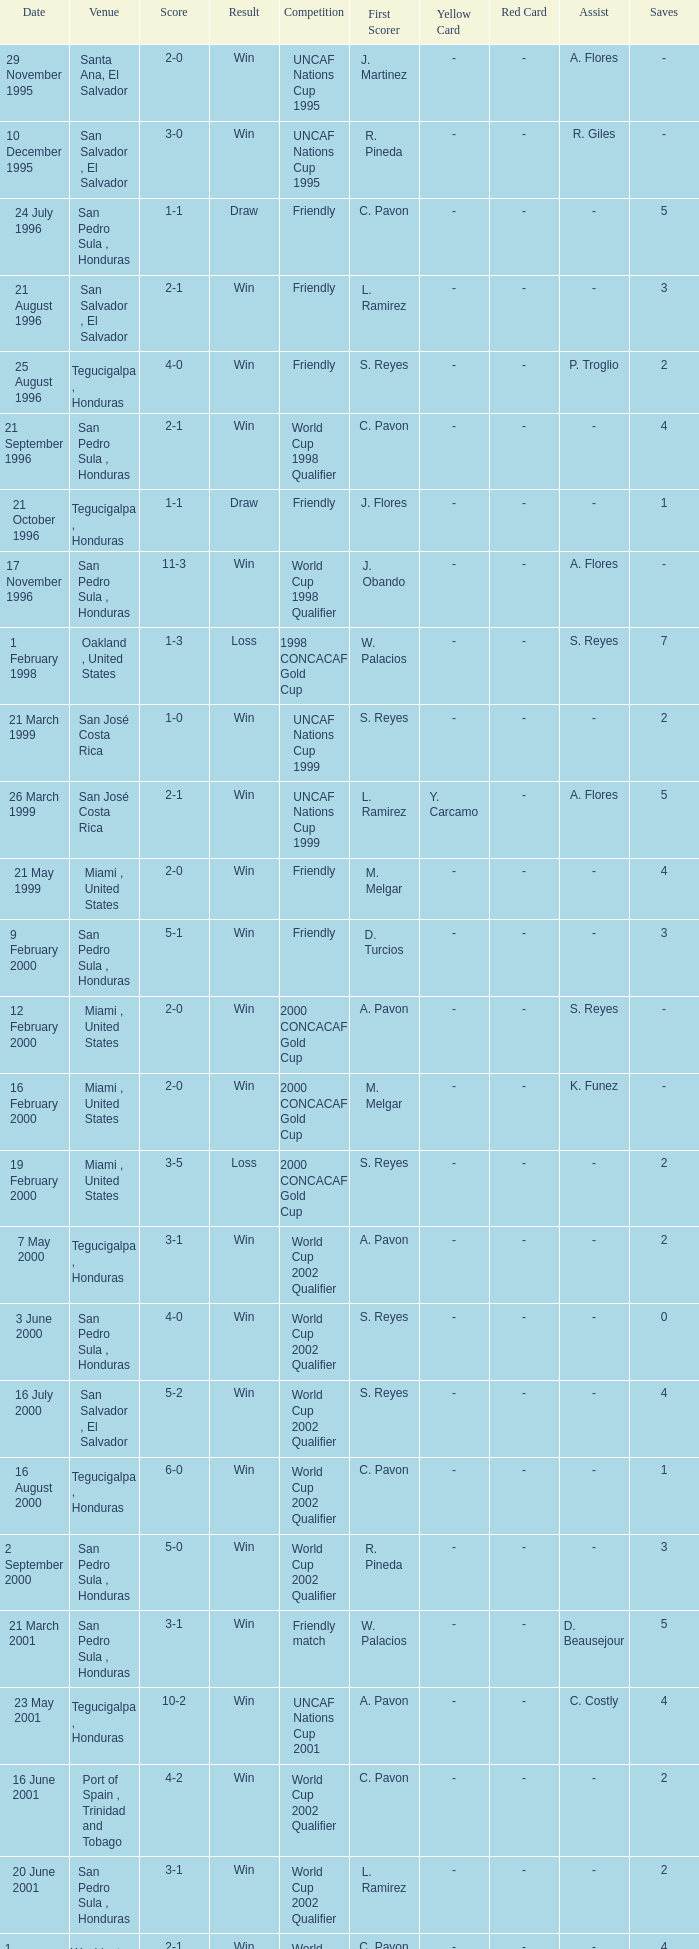Name the score for 7 may 2000 3-1. 